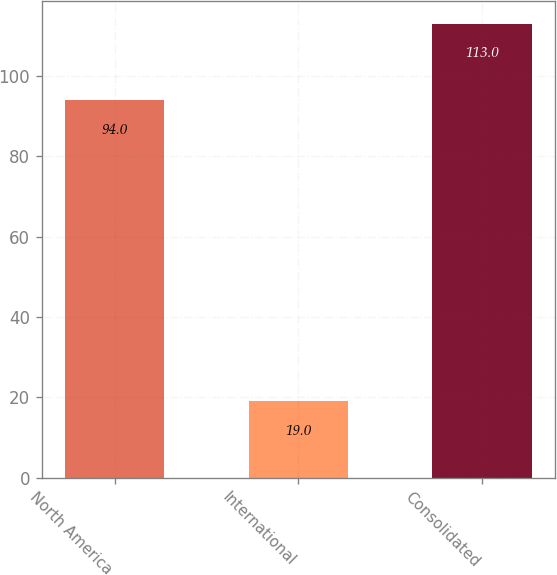<chart> <loc_0><loc_0><loc_500><loc_500><bar_chart><fcel>North America<fcel>International<fcel>Consolidated<nl><fcel>94<fcel>19<fcel>113<nl></chart> 